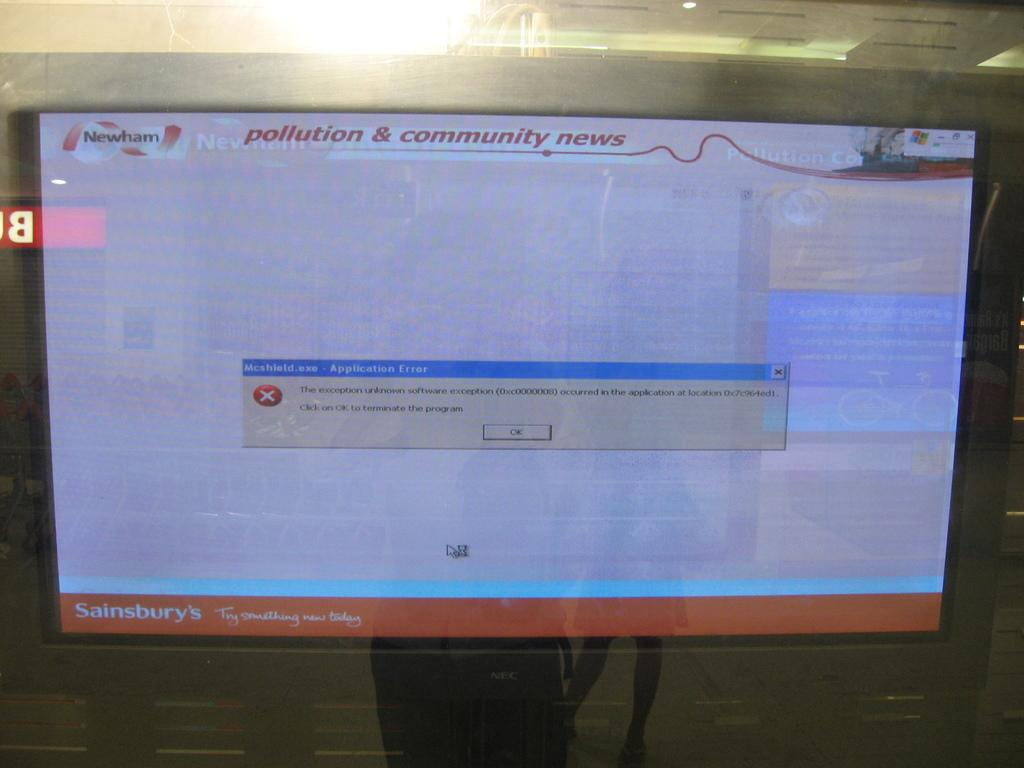<image>
Present a compact description of the photo's key features. An error message appears on the pollution and community news site. 